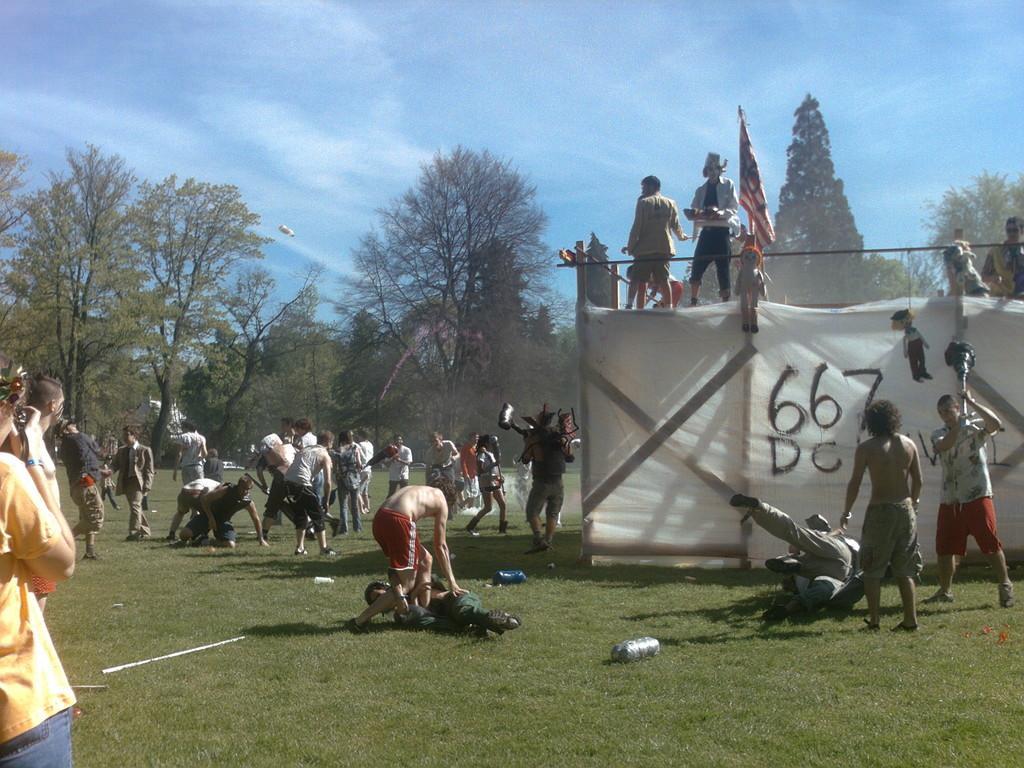In one or two sentences, can you explain what this image depicts? In this image I can see few people around. In front I can see white color cloth and a flag. Back Side I can see trees. The sky is in blue and white color. The person is holding something and we can see few object on the ground. 